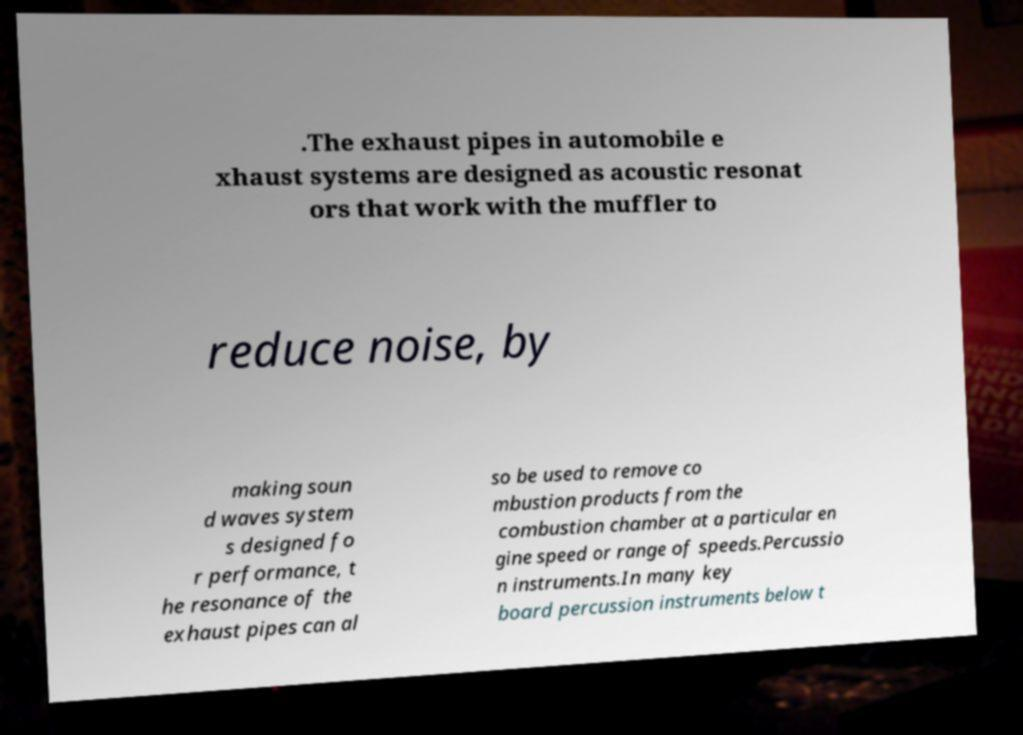Please read and relay the text visible in this image. What does it say? .The exhaust pipes in automobile e xhaust systems are designed as acoustic resonat ors that work with the muffler to reduce noise, by making soun d waves system s designed fo r performance, t he resonance of the exhaust pipes can al so be used to remove co mbustion products from the combustion chamber at a particular en gine speed or range of speeds.Percussio n instruments.In many key board percussion instruments below t 